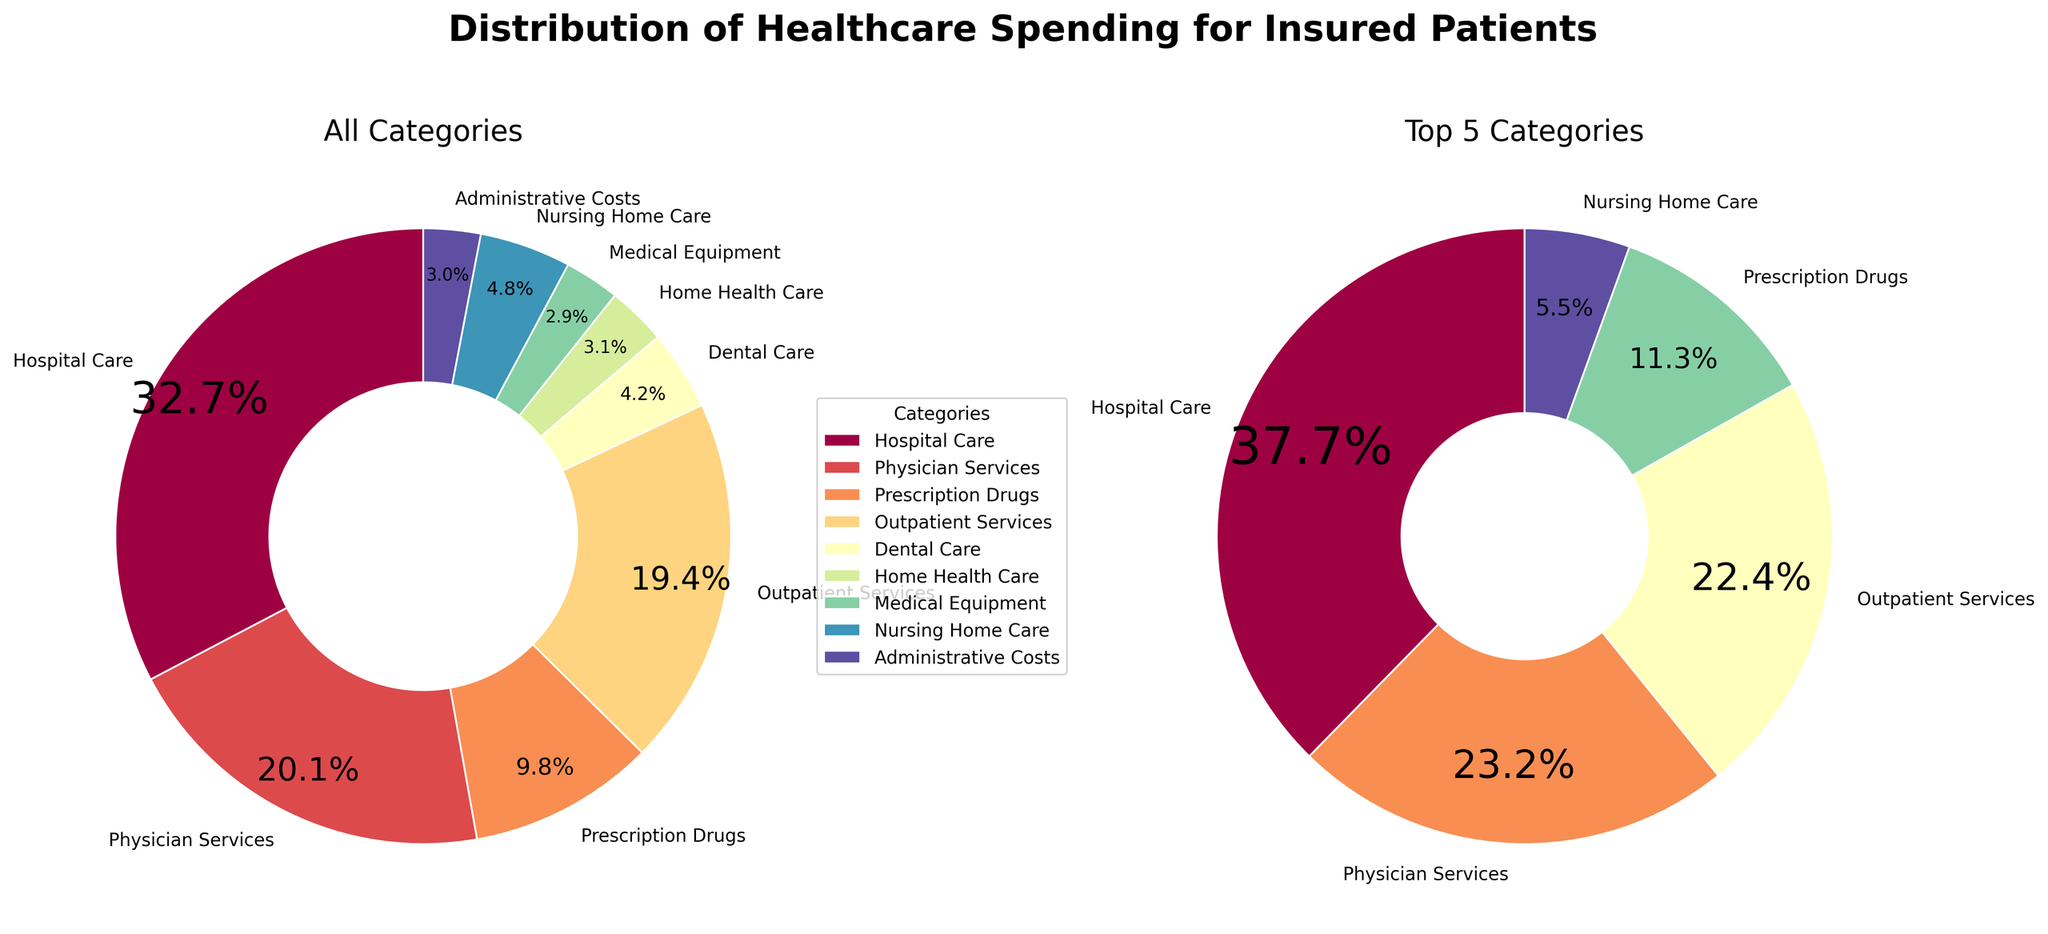What is the title of the overall figure? The title of the overall figure is found at the top of the plot and summarizes the visual information depicted. It is useful for understanding the context and the scope of the data.
Answer: Distribution of Healthcare Spending for Insured Patients Which category has the highest percentage in the main pie chart? By observing the main pie chart, the largest wedge will typically indicate the category with the highest percentage. This category is often labeled on the plot with a percentage value.
Answer: Hospital Care How much higher is the percentage of Hospital Care compared to Home Health Care? Locate the percentage values for both Hospital Care and Home Health Care in the main pie chart or the legend. Subtract the percentage of Home Health Care from the percentage of Hospital Care to find the difference.
Answer: 32.7% - 3.1% = 29.6% Which categories are included in the top 5 spending chart? The smaller pie chart on the right displays the top 5 categories. Identify the labels next to these wedges to determine the categories.
Answer: Hospital Care, Physician Services, Outpatient Services, Prescription Drugs, Nursing Home Care What is the combined percentage of Dental Care, Medical Equipment, and Administrative Costs? Add the percentage values of Dental Care, Medical Equipment, and Administrative Costs by using the legend or the main pie chart.
Answer: 4.2% + 2.9% + 3.0% = 10.1% Is Physician Services spending higher than Prescription Drugs spending? Compare the percentage values for Physician Services and Prescription Drugs in either pie chart. The wedge with the larger percentage indicates higher spending.
Answer: Yes How many categories have a percentage under 5%? Count the number of categories in the legend or the pie chart display with percentage values below 5%.
Answer: 5 (Dental Care, Home Health Care, Medical Equipment, Nursing Home Care, Administrative Costs) Which chart has a wider wedge for Outpatient Services, the main pie chart or the top 5 chart? Compare the size of the wedge representing Outpatient Services in both pie charts. The wedge with a more substantial angle indicates a wider representation.
Answer: Main Pie Chart What percentage do the top 5 categories represent together? Add the percentage values of the top 5 categories found in the smaller pie chart. This total gives the combined representation in terms of healthcare spending.
Answer: 32.7 + 20.1 + 19.4 + 9.8 + 4.8 = 86.8% 